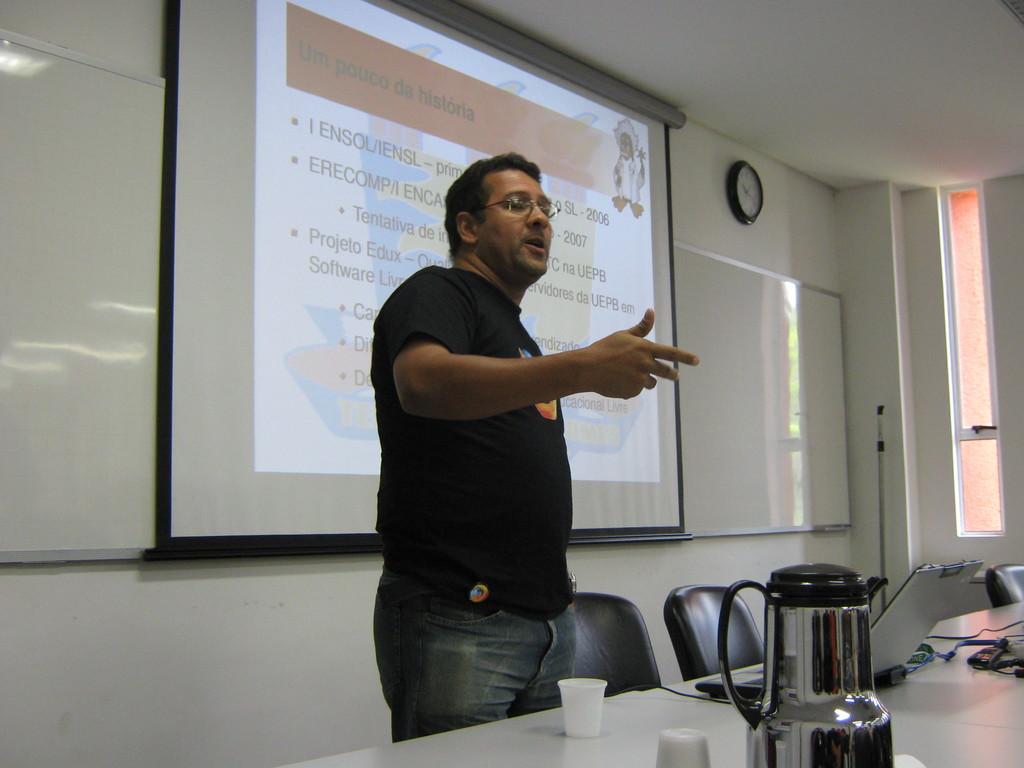What's the title of the current slide?
Keep it short and to the point. Um pouco da historia. 